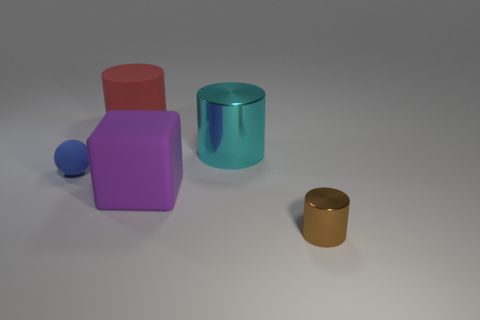Could you imagine a practical use for each of these objects if they were real? Creative thinking! The red cube could serve as a dice or a paperweight, the purple cuboid might be a toy block, the blue sphere could be a marble, the teal cylinder could resemble a mug without a handle, and the gold cylinder could be a decorative container or a small vase. How do the colors of these objects influence their perceived texture? Great observation. The colors, along with the lighting, play a role in the perception of texture. The metallic sheen of the blue sphere and gold cylinder gives off a smooth and reflective quality. The matte finish of the red cube and purple cuboid suggests a more solid, non-reflective surface that could be softer to the touch. 